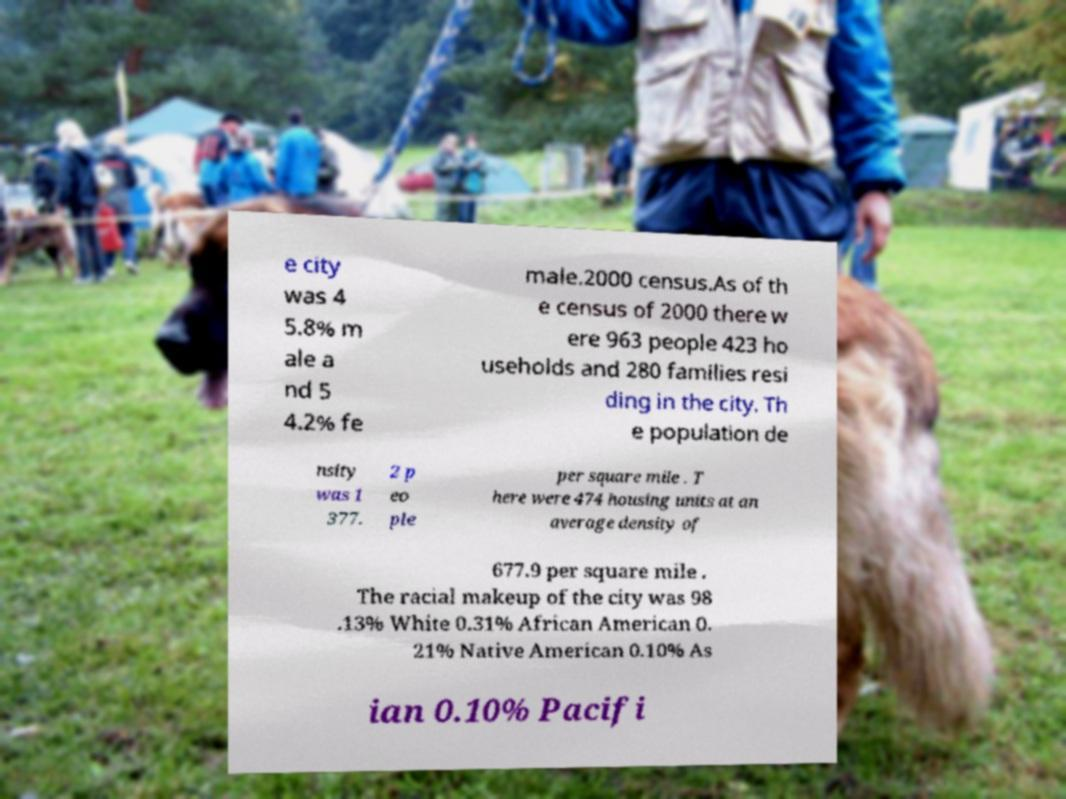Please read and relay the text visible in this image. What does it say? e city was 4 5.8% m ale a nd 5 4.2% fe male.2000 census.As of th e census of 2000 there w ere 963 people 423 ho useholds and 280 families resi ding in the city. Th e population de nsity was 1 377. 2 p eo ple per square mile . T here were 474 housing units at an average density of 677.9 per square mile . The racial makeup of the city was 98 .13% White 0.31% African American 0. 21% Native American 0.10% As ian 0.10% Pacifi 